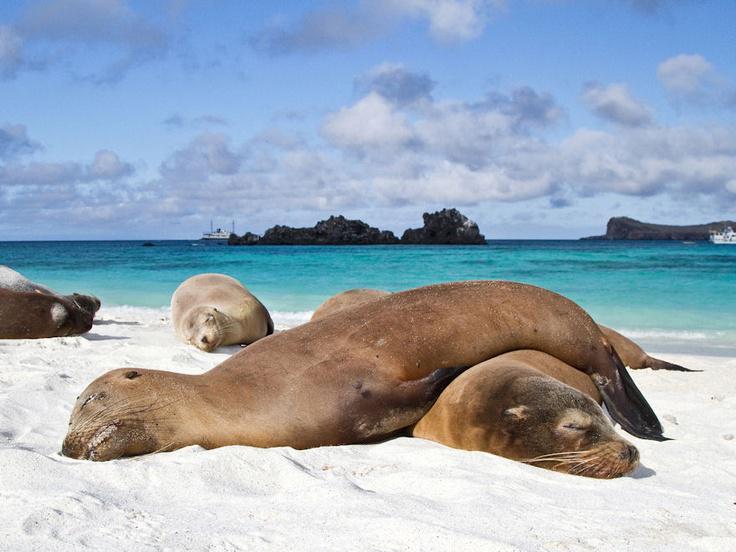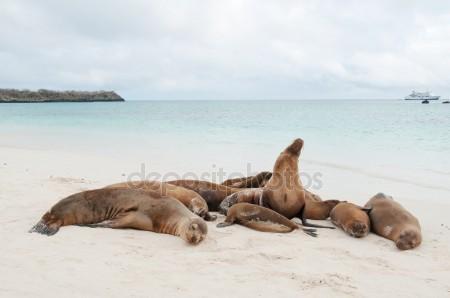The first image is the image on the left, the second image is the image on the right. Assess this claim about the two images: "Two seals are lying in the sand in the image on the right.". Correct or not? Answer yes or no. No. The first image is the image on the left, the second image is the image on the right. Evaluate the accuracy of this statement regarding the images: "One image contains no more than two seals, who lie horizontally on the beach, and the other image shows seals lying lengthwise, head-first on the beach.". Is it true? Answer yes or no. No. 